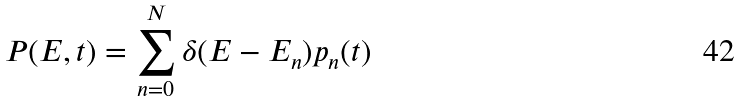<formula> <loc_0><loc_0><loc_500><loc_500>P ( E , t ) = \sum _ { n = 0 } ^ { N } \delta ( E - E _ { n } ) p _ { n } ( t )</formula> 